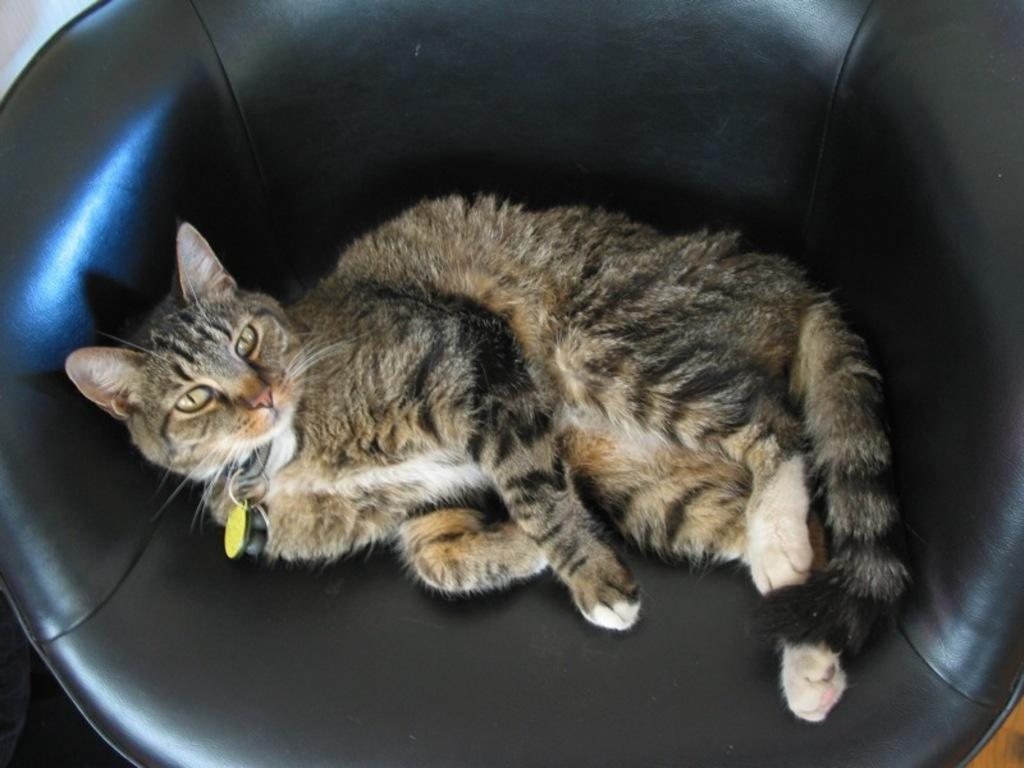What type of animal is in the image? There is a cat in the image. What is the cat doing in the image? The cat is laying on a chair. What color is the chair the cat is laying on? The chair is black in color. What type of milk is the cat drinking in the image? There is no milk present in the image; the cat is laying on a chair. 